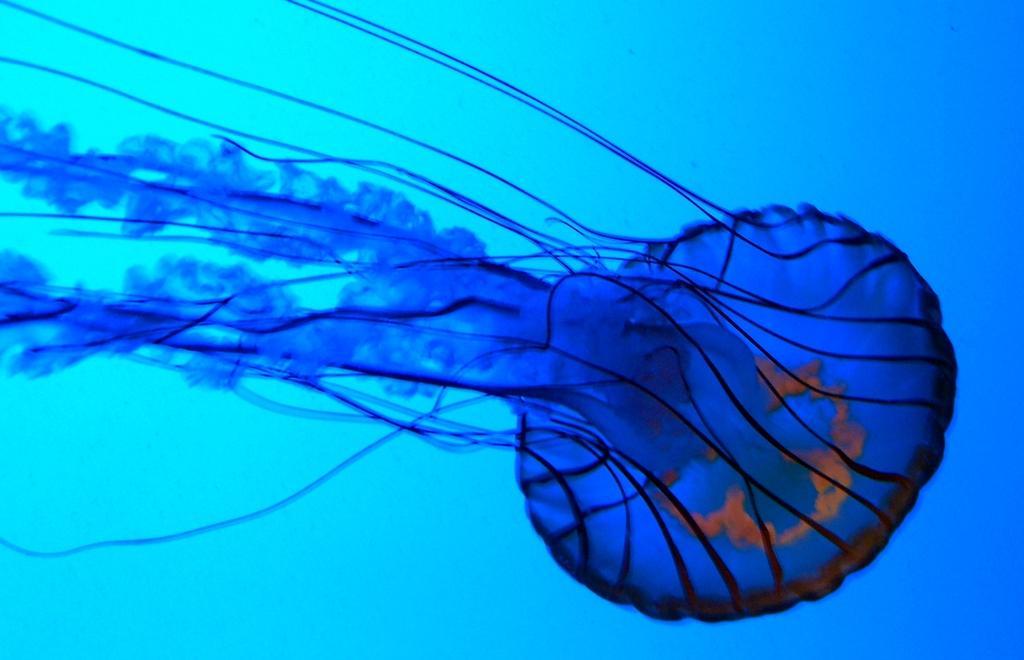Can you describe this image briefly? In this image we can see a jellyfish, and the background is blue. 